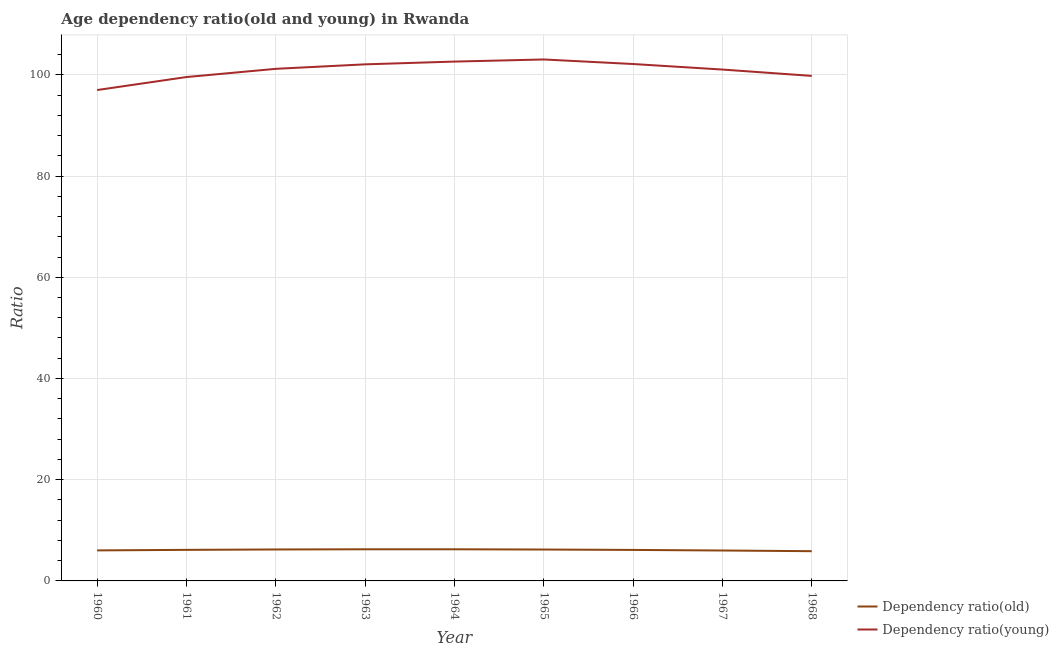How many different coloured lines are there?
Make the answer very short. 2. Does the line corresponding to age dependency ratio(young) intersect with the line corresponding to age dependency ratio(old)?
Offer a very short reply. No. What is the age dependency ratio(young) in 1962?
Your response must be concise. 101.18. Across all years, what is the maximum age dependency ratio(young)?
Your response must be concise. 103.03. Across all years, what is the minimum age dependency ratio(old)?
Provide a short and direct response. 5.87. In which year was the age dependency ratio(old) maximum?
Your answer should be very brief. 1963. In which year was the age dependency ratio(old) minimum?
Your answer should be compact. 1968. What is the total age dependency ratio(young) in the graph?
Your response must be concise. 908.38. What is the difference between the age dependency ratio(young) in 1961 and that in 1965?
Give a very brief answer. -3.47. What is the difference between the age dependency ratio(old) in 1961 and the age dependency ratio(young) in 1963?
Offer a very short reply. -95.93. What is the average age dependency ratio(young) per year?
Keep it short and to the point. 100.93. In the year 1961, what is the difference between the age dependency ratio(young) and age dependency ratio(old)?
Provide a short and direct response. 93.42. What is the ratio of the age dependency ratio(old) in 1961 to that in 1965?
Your response must be concise. 0.99. Is the age dependency ratio(old) in 1960 less than that in 1965?
Provide a succinct answer. Yes. Is the difference between the age dependency ratio(old) in 1962 and 1964 greater than the difference between the age dependency ratio(young) in 1962 and 1964?
Give a very brief answer. Yes. What is the difference between the highest and the second highest age dependency ratio(old)?
Ensure brevity in your answer.  0. What is the difference between the highest and the lowest age dependency ratio(young)?
Offer a very short reply. 6.04. In how many years, is the age dependency ratio(old) greater than the average age dependency ratio(old) taken over all years?
Offer a terse response. 6. Is the sum of the age dependency ratio(old) in 1961 and 1962 greater than the maximum age dependency ratio(young) across all years?
Provide a succinct answer. No. Does the age dependency ratio(young) monotonically increase over the years?
Make the answer very short. No. Is the age dependency ratio(old) strictly greater than the age dependency ratio(young) over the years?
Give a very brief answer. No. Is the age dependency ratio(old) strictly less than the age dependency ratio(young) over the years?
Provide a succinct answer. Yes. How many lines are there?
Offer a terse response. 2. What is the difference between two consecutive major ticks on the Y-axis?
Keep it short and to the point. 20. Are the values on the major ticks of Y-axis written in scientific E-notation?
Ensure brevity in your answer.  No. Where does the legend appear in the graph?
Provide a short and direct response. Bottom right. What is the title of the graph?
Ensure brevity in your answer.  Age dependency ratio(old and young) in Rwanda. Does "% of gross capital formation" appear as one of the legend labels in the graph?
Offer a terse response. No. What is the label or title of the Y-axis?
Your answer should be very brief. Ratio. What is the Ratio of Dependency ratio(old) in 1960?
Ensure brevity in your answer.  6.03. What is the Ratio in Dependency ratio(young) in 1960?
Your answer should be compact. 96.99. What is the Ratio of Dependency ratio(old) in 1961?
Make the answer very short. 6.14. What is the Ratio of Dependency ratio(young) in 1961?
Make the answer very short. 99.56. What is the Ratio of Dependency ratio(old) in 1962?
Make the answer very short. 6.21. What is the Ratio in Dependency ratio(young) in 1962?
Your answer should be compact. 101.18. What is the Ratio of Dependency ratio(old) in 1963?
Offer a terse response. 6.25. What is the Ratio of Dependency ratio(young) in 1963?
Your response must be concise. 102.07. What is the Ratio in Dependency ratio(old) in 1964?
Keep it short and to the point. 6.25. What is the Ratio of Dependency ratio(young) in 1964?
Give a very brief answer. 102.61. What is the Ratio of Dependency ratio(old) in 1965?
Your answer should be compact. 6.2. What is the Ratio in Dependency ratio(young) in 1965?
Make the answer very short. 103.03. What is the Ratio of Dependency ratio(old) in 1966?
Offer a very short reply. 6.12. What is the Ratio of Dependency ratio(young) in 1966?
Offer a terse response. 102.13. What is the Ratio of Dependency ratio(old) in 1967?
Offer a terse response. 6.01. What is the Ratio in Dependency ratio(young) in 1967?
Give a very brief answer. 101.04. What is the Ratio of Dependency ratio(old) in 1968?
Provide a succinct answer. 5.87. What is the Ratio of Dependency ratio(young) in 1968?
Keep it short and to the point. 99.78. Across all years, what is the maximum Ratio in Dependency ratio(old)?
Your answer should be very brief. 6.25. Across all years, what is the maximum Ratio of Dependency ratio(young)?
Your answer should be very brief. 103.03. Across all years, what is the minimum Ratio in Dependency ratio(old)?
Your answer should be compact. 5.87. Across all years, what is the minimum Ratio in Dependency ratio(young)?
Your answer should be very brief. 96.99. What is the total Ratio of Dependency ratio(old) in the graph?
Keep it short and to the point. 55.1. What is the total Ratio of Dependency ratio(young) in the graph?
Ensure brevity in your answer.  908.38. What is the difference between the Ratio in Dependency ratio(old) in 1960 and that in 1961?
Your answer should be very brief. -0.1. What is the difference between the Ratio of Dependency ratio(young) in 1960 and that in 1961?
Your answer should be very brief. -2.57. What is the difference between the Ratio of Dependency ratio(old) in 1960 and that in 1962?
Your response must be concise. -0.18. What is the difference between the Ratio in Dependency ratio(young) in 1960 and that in 1962?
Your response must be concise. -4.19. What is the difference between the Ratio in Dependency ratio(old) in 1960 and that in 1963?
Provide a succinct answer. -0.22. What is the difference between the Ratio in Dependency ratio(young) in 1960 and that in 1963?
Make the answer very short. -5.08. What is the difference between the Ratio of Dependency ratio(old) in 1960 and that in 1964?
Make the answer very short. -0.22. What is the difference between the Ratio of Dependency ratio(young) in 1960 and that in 1964?
Your answer should be compact. -5.62. What is the difference between the Ratio of Dependency ratio(old) in 1960 and that in 1965?
Provide a succinct answer. -0.17. What is the difference between the Ratio in Dependency ratio(young) in 1960 and that in 1965?
Offer a terse response. -6.04. What is the difference between the Ratio in Dependency ratio(old) in 1960 and that in 1966?
Your answer should be very brief. -0.09. What is the difference between the Ratio in Dependency ratio(young) in 1960 and that in 1966?
Provide a short and direct response. -5.14. What is the difference between the Ratio of Dependency ratio(old) in 1960 and that in 1967?
Provide a succinct answer. 0.02. What is the difference between the Ratio of Dependency ratio(young) in 1960 and that in 1967?
Ensure brevity in your answer.  -4.05. What is the difference between the Ratio of Dependency ratio(old) in 1960 and that in 1968?
Your response must be concise. 0.16. What is the difference between the Ratio of Dependency ratio(young) in 1960 and that in 1968?
Offer a very short reply. -2.8. What is the difference between the Ratio of Dependency ratio(old) in 1961 and that in 1962?
Your answer should be very brief. -0.07. What is the difference between the Ratio of Dependency ratio(young) in 1961 and that in 1962?
Keep it short and to the point. -1.62. What is the difference between the Ratio of Dependency ratio(old) in 1961 and that in 1963?
Provide a short and direct response. -0.11. What is the difference between the Ratio in Dependency ratio(young) in 1961 and that in 1963?
Offer a terse response. -2.51. What is the difference between the Ratio of Dependency ratio(old) in 1961 and that in 1964?
Provide a short and direct response. -0.11. What is the difference between the Ratio of Dependency ratio(young) in 1961 and that in 1964?
Your answer should be very brief. -3.06. What is the difference between the Ratio of Dependency ratio(old) in 1961 and that in 1965?
Provide a short and direct response. -0.06. What is the difference between the Ratio of Dependency ratio(young) in 1961 and that in 1965?
Offer a terse response. -3.47. What is the difference between the Ratio of Dependency ratio(old) in 1961 and that in 1966?
Offer a terse response. 0.01. What is the difference between the Ratio of Dependency ratio(young) in 1961 and that in 1966?
Offer a very short reply. -2.57. What is the difference between the Ratio of Dependency ratio(old) in 1961 and that in 1967?
Your answer should be very brief. 0.13. What is the difference between the Ratio in Dependency ratio(young) in 1961 and that in 1967?
Ensure brevity in your answer.  -1.48. What is the difference between the Ratio in Dependency ratio(old) in 1961 and that in 1968?
Your answer should be compact. 0.26. What is the difference between the Ratio in Dependency ratio(young) in 1961 and that in 1968?
Your answer should be compact. -0.23. What is the difference between the Ratio in Dependency ratio(old) in 1962 and that in 1963?
Offer a very short reply. -0.04. What is the difference between the Ratio in Dependency ratio(young) in 1962 and that in 1963?
Make the answer very short. -0.89. What is the difference between the Ratio of Dependency ratio(old) in 1962 and that in 1964?
Give a very brief answer. -0.04. What is the difference between the Ratio of Dependency ratio(young) in 1962 and that in 1964?
Offer a very short reply. -1.43. What is the difference between the Ratio of Dependency ratio(old) in 1962 and that in 1965?
Provide a short and direct response. 0.01. What is the difference between the Ratio of Dependency ratio(young) in 1962 and that in 1965?
Keep it short and to the point. -1.85. What is the difference between the Ratio in Dependency ratio(old) in 1962 and that in 1966?
Keep it short and to the point. 0.09. What is the difference between the Ratio of Dependency ratio(young) in 1962 and that in 1966?
Provide a succinct answer. -0.95. What is the difference between the Ratio of Dependency ratio(old) in 1962 and that in 1967?
Make the answer very short. 0.2. What is the difference between the Ratio of Dependency ratio(young) in 1962 and that in 1967?
Keep it short and to the point. 0.14. What is the difference between the Ratio of Dependency ratio(old) in 1962 and that in 1968?
Offer a terse response. 0.34. What is the difference between the Ratio of Dependency ratio(young) in 1962 and that in 1968?
Make the answer very short. 1.39. What is the difference between the Ratio in Dependency ratio(old) in 1963 and that in 1964?
Make the answer very short. 0. What is the difference between the Ratio of Dependency ratio(young) in 1963 and that in 1964?
Your answer should be very brief. -0.55. What is the difference between the Ratio in Dependency ratio(young) in 1963 and that in 1965?
Make the answer very short. -0.96. What is the difference between the Ratio in Dependency ratio(old) in 1963 and that in 1966?
Make the answer very short. 0.13. What is the difference between the Ratio in Dependency ratio(young) in 1963 and that in 1966?
Keep it short and to the point. -0.06. What is the difference between the Ratio in Dependency ratio(old) in 1963 and that in 1967?
Offer a very short reply. 0.24. What is the difference between the Ratio in Dependency ratio(young) in 1963 and that in 1967?
Ensure brevity in your answer.  1.03. What is the difference between the Ratio of Dependency ratio(old) in 1963 and that in 1968?
Provide a short and direct response. 0.38. What is the difference between the Ratio in Dependency ratio(young) in 1963 and that in 1968?
Offer a very short reply. 2.28. What is the difference between the Ratio in Dependency ratio(old) in 1964 and that in 1965?
Your answer should be compact. 0.05. What is the difference between the Ratio in Dependency ratio(young) in 1964 and that in 1965?
Make the answer very short. -0.42. What is the difference between the Ratio in Dependency ratio(old) in 1964 and that in 1966?
Offer a terse response. 0.13. What is the difference between the Ratio of Dependency ratio(young) in 1964 and that in 1966?
Offer a terse response. 0.48. What is the difference between the Ratio in Dependency ratio(old) in 1964 and that in 1967?
Provide a succinct answer. 0.24. What is the difference between the Ratio in Dependency ratio(young) in 1964 and that in 1967?
Keep it short and to the point. 1.57. What is the difference between the Ratio in Dependency ratio(old) in 1964 and that in 1968?
Make the answer very short. 0.38. What is the difference between the Ratio of Dependency ratio(young) in 1964 and that in 1968?
Provide a succinct answer. 2.83. What is the difference between the Ratio of Dependency ratio(old) in 1965 and that in 1966?
Offer a terse response. 0.08. What is the difference between the Ratio of Dependency ratio(young) in 1965 and that in 1966?
Keep it short and to the point. 0.9. What is the difference between the Ratio in Dependency ratio(old) in 1965 and that in 1967?
Your response must be concise. 0.19. What is the difference between the Ratio in Dependency ratio(young) in 1965 and that in 1967?
Provide a succinct answer. 1.99. What is the difference between the Ratio in Dependency ratio(old) in 1965 and that in 1968?
Offer a very short reply. 0.33. What is the difference between the Ratio in Dependency ratio(young) in 1965 and that in 1968?
Make the answer very short. 3.25. What is the difference between the Ratio of Dependency ratio(old) in 1966 and that in 1967?
Offer a very short reply. 0.11. What is the difference between the Ratio in Dependency ratio(young) in 1966 and that in 1967?
Provide a succinct answer. 1.09. What is the difference between the Ratio of Dependency ratio(old) in 1966 and that in 1968?
Your response must be concise. 0.25. What is the difference between the Ratio in Dependency ratio(young) in 1966 and that in 1968?
Your response must be concise. 2.35. What is the difference between the Ratio in Dependency ratio(old) in 1967 and that in 1968?
Provide a succinct answer. 0.14. What is the difference between the Ratio of Dependency ratio(young) in 1967 and that in 1968?
Provide a succinct answer. 1.25. What is the difference between the Ratio in Dependency ratio(old) in 1960 and the Ratio in Dependency ratio(young) in 1961?
Your answer should be very brief. -93.52. What is the difference between the Ratio in Dependency ratio(old) in 1960 and the Ratio in Dependency ratio(young) in 1962?
Your response must be concise. -95.14. What is the difference between the Ratio of Dependency ratio(old) in 1960 and the Ratio of Dependency ratio(young) in 1963?
Offer a very short reply. -96.03. What is the difference between the Ratio of Dependency ratio(old) in 1960 and the Ratio of Dependency ratio(young) in 1964?
Offer a very short reply. -96.58. What is the difference between the Ratio of Dependency ratio(old) in 1960 and the Ratio of Dependency ratio(young) in 1965?
Give a very brief answer. -97. What is the difference between the Ratio of Dependency ratio(old) in 1960 and the Ratio of Dependency ratio(young) in 1966?
Your answer should be very brief. -96.1. What is the difference between the Ratio in Dependency ratio(old) in 1960 and the Ratio in Dependency ratio(young) in 1967?
Offer a terse response. -95. What is the difference between the Ratio in Dependency ratio(old) in 1960 and the Ratio in Dependency ratio(young) in 1968?
Make the answer very short. -93.75. What is the difference between the Ratio in Dependency ratio(old) in 1961 and the Ratio in Dependency ratio(young) in 1962?
Give a very brief answer. -95.04. What is the difference between the Ratio in Dependency ratio(old) in 1961 and the Ratio in Dependency ratio(young) in 1963?
Offer a very short reply. -95.93. What is the difference between the Ratio of Dependency ratio(old) in 1961 and the Ratio of Dependency ratio(young) in 1964?
Offer a very short reply. -96.47. What is the difference between the Ratio in Dependency ratio(old) in 1961 and the Ratio in Dependency ratio(young) in 1965?
Your answer should be very brief. -96.89. What is the difference between the Ratio of Dependency ratio(old) in 1961 and the Ratio of Dependency ratio(young) in 1966?
Offer a terse response. -95.99. What is the difference between the Ratio of Dependency ratio(old) in 1961 and the Ratio of Dependency ratio(young) in 1967?
Make the answer very short. -94.9. What is the difference between the Ratio in Dependency ratio(old) in 1961 and the Ratio in Dependency ratio(young) in 1968?
Your answer should be very brief. -93.65. What is the difference between the Ratio of Dependency ratio(old) in 1962 and the Ratio of Dependency ratio(young) in 1963?
Make the answer very short. -95.85. What is the difference between the Ratio of Dependency ratio(old) in 1962 and the Ratio of Dependency ratio(young) in 1964?
Your answer should be very brief. -96.4. What is the difference between the Ratio of Dependency ratio(old) in 1962 and the Ratio of Dependency ratio(young) in 1965?
Offer a terse response. -96.82. What is the difference between the Ratio in Dependency ratio(old) in 1962 and the Ratio in Dependency ratio(young) in 1966?
Provide a short and direct response. -95.92. What is the difference between the Ratio in Dependency ratio(old) in 1962 and the Ratio in Dependency ratio(young) in 1967?
Ensure brevity in your answer.  -94.82. What is the difference between the Ratio of Dependency ratio(old) in 1962 and the Ratio of Dependency ratio(young) in 1968?
Ensure brevity in your answer.  -93.57. What is the difference between the Ratio of Dependency ratio(old) in 1963 and the Ratio of Dependency ratio(young) in 1964?
Your answer should be very brief. -96.36. What is the difference between the Ratio in Dependency ratio(old) in 1963 and the Ratio in Dependency ratio(young) in 1965?
Your answer should be compact. -96.78. What is the difference between the Ratio in Dependency ratio(old) in 1963 and the Ratio in Dependency ratio(young) in 1966?
Your answer should be compact. -95.88. What is the difference between the Ratio of Dependency ratio(old) in 1963 and the Ratio of Dependency ratio(young) in 1967?
Give a very brief answer. -94.78. What is the difference between the Ratio of Dependency ratio(old) in 1963 and the Ratio of Dependency ratio(young) in 1968?
Your answer should be compact. -93.53. What is the difference between the Ratio in Dependency ratio(old) in 1964 and the Ratio in Dependency ratio(young) in 1965?
Provide a succinct answer. -96.78. What is the difference between the Ratio in Dependency ratio(old) in 1964 and the Ratio in Dependency ratio(young) in 1966?
Your response must be concise. -95.88. What is the difference between the Ratio of Dependency ratio(old) in 1964 and the Ratio of Dependency ratio(young) in 1967?
Provide a succinct answer. -94.79. What is the difference between the Ratio of Dependency ratio(old) in 1964 and the Ratio of Dependency ratio(young) in 1968?
Give a very brief answer. -93.53. What is the difference between the Ratio of Dependency ratio(old) in 1965 and the Ratio of Dependency ratio(young) in 1966?
Give a very brief answer. -95.93. What is the difference between the Ratio in Dependency ratio(old) in 1965 and the Ratio in Dependency ratio(young) in 1967?
Offer a terse response. -94.83. What is the difference between the Ratio of Dependency ratio(old) in 1965 and the Ratio of Dependency ratio(young) in 1968?
Offer a very short reply. -93.58. What is the difference between the Ratio in Dependency ratio(old) in 1966 and the Ratio in Dependency ratio(young) in 1967?
Provide a succinct answer. -94.91. What is the difference between the Ratio of Dependency ratio(old) in 1966 and the Ratio of Dependency ratio(young) in 1968?
Provide a succinct answer. -93.66. What is the difference between the Ratio of Dependency ratio(old) in 1967 and the Ratio of Dependency ratio(young) in 1968?
Make the answer very short. -93.77. What is the average Ratio of Dependency ratio(old) per year?
Offer a very short reply. 6.12. What is the average Ratio of Dependency ratio(young) per year?
Ensure brevity in your answer.  100.93. In the year 1960, what is the difference between the Ratio in Dependency ratio(old) and Ratio in Dependency ratio(young)?
Keep it short and to the point. -90.95. In the year 1961, what is the difference between the Ratio in Dependency ratio(old) and Ratio in Dependency ratio(young)?
Make the answer very short. -93.42. In the year 1962, what is the difference between the Ratio of Dependency ratio(old) and Ratio of Dependency ratio(young)?
Offer a terse response. -94.97. In the year 1963, what is the difference between the Ratio of Dependency ratio(old) and Ratio of Dependency ratio(young)?
Give a very brief answer. -95.81. In the year 1964, what is the difference between the Ratio in Dependency ratio(old) and Ratio in Dependency ratio(young)?
Your response must be concise. -96.36. In the year 1965, what is the difference between the Ratio in Dependency ratio(old) and Ratio in Dependency ratio(young)?
Your response must be concise. -96.83. In the year 1966, what is the difference between the Ratio in Dependency ratio(old) and Ratio in Dependency ratio(young)?
Offer a terse response. -96.01. In the year 1967, what is the difference between the Ratio in Dependency ratio(old) and Ratio in Dependency ratio(young)?
Keep it short and to the point. -95.03. In the year 1968, what is the difference between the Ratio of Dependency ratio(old) and Ratio of Dependency ratio(young)?
Make the answer very short. -93.91. What is the ratio of the Ratio in Dependency ratio(young) in 1960 to that in 1961?
Provide a short and direct response. 0.97. What is the ratio of the Ratio in Dependency ratio(old) in 1960 to that in 1962?
Your response must be concise. 0.97. What is the ratio of the Ratio of Dependency ratio(young) in 1960 to that in 1962?
Make the answer very short. 0.96. What is the ratio of the Ratio in Dependency ratio(young) in 1960 to that in 1963?
Your answer should be very brief. 0.95. What is the ratio of the Ratio in Dependency ratio(old) in 1960 to that in 1964?
Keep it short and to the point. 0.97. What is the ratio of the Ratio in Dependency ratio(young) in 1960 to that in 1964?
Your response must be concise. 0.95. What is the ratio of the Ratio of Dependency ratio(old) in 1960 to that in 1965?
Your answer should be compact. 0.97. What is the ratio of the Ratio in Dependency ratio(young) in 1960 to that in 1965?
Your answer should be very brief. 0.94. What is the ratio of the Ratio in Dependency ratio(old) in 1960 to that in 1966?
Provide a succinct answer. 0.99. What is the ratio of the Ratio of Dependency ratio(young) in 1960 to that in 1966?
Offer a terse response. 0.95. What is the ratio of the Ratio in Dependency ratio(old) in 1960 to that in 1967?
Offer a very short reply. 1. What is the ratio of the Ratio in Dependency ratio(young) in 1960 to that in 1967?
Give a very brief answer. 0.96. What is the ratio of the Ratio in Dependency ratio(old) in 1960 to that in 1968?
Your answer should be very brief. 1.03. What is the ratio of the Ratio in Dependency ratio(young) in 1960 to that in 1968?
Provide a short and direct response. 0.97. What is the ratio of the Ratio in Dependency ratio(old) in 1961 to that in 1962?
Your response must be concise. 0.99. What is the ratio of the Ratio of Dependency ratio(young) in 1961 to that in 1962?
Give a very brief answer. 0.98. What is the ratio of the Ratio of Dependency ratio(old) in 1961 to that in 1963?
Give a very brief answer. 0.98. What is the ratio of the Ratio in Dependency ratio(young) in 1961 to that in 1963?
Ensure brevity in your answer.  0.98. What is the ratio of the Ratio of Dependency ratio(old) in 1961 to that in 1964?
Your answer should be compact. 0.98. What is the ratio of the Ratio of Dependency ratio(young) in 1961 to that in 1964?
Offer a terse response. 0.97. What is the ratio of the Ratio of Dependency ratio(old) in 1961 to that in 1965?
Ensure brevity in your answer.  0.99. What is the ratio of the Ratio of Dependency ratio(young) in 1961 to that in 1965?
Provide a succinct answer. 0.97. What is the ratio of the Ratio of Dependency ratio(young) in 1961 to that in 1966?
Your answer should be compact. 0.97. What is the ratio of the Ratio in Dependency ratio(old) in 1961 to that in 1967?
Ensure brevity in your answer.  1.02. What is the ratio of the Ratio in Dependency ratio(old) in 1961 to that in 1968?
Give a very brief answer. 1.04. What is the ratio of the Ratio of Dependency ratio(young) in 1961 to that in 1968?
Your answer should be compact. 1. What is the ratio of the Ratio of Dependency ratio(young) in 1962 to that in 1964?
Give a very brief answer. 0.99. What is the ratio of the Ratio in Dependency ratio(old) in 1962 to that in 1965?
Your response must be concise. 1. What is the ratio of the Ratio in Dependency ratio(old) in 1962 to that in 1966?
Give a very brief answer. 1.01. What is the ratio of the Ratio of Dependency ratio(young) in 1962 to that in 1966?
Your response must be concise. 0.99. What is the ratio of the Ratio of Dependency ratio(old) in 1962 to that in 1967?
Provide a succinct answer. 1.03. What is the ratio of the Ratio of Dependency ratio(old) in 1962 to that in 1968?
Provide a succinct answer. 1.06. What is the ratio of the Ratio in Dependency ratio(young) in 1962 to that in 1968?
Provide a short and direct response. 1.01. What is the ratio of the Ratio in Dependency ratio(old) in 1963 to that in 1964?
Offer a very short reply. 1. What is the ratio of the Ratio of Dependency ratio(old) in 1963 to that in 1965?
Your answer should be very brief. 1.01. What is the ratio of the Ratio of Dependency ratio(young) in 1963 to that in 1965?
Give a very brief answer. 0.99. What is the ratio of the Ratio in Dependency ratio(old) in 1963 to that in 1966?
Make the answer very short. 1.02. What is the ratio of the Ratio in Dependency ratio(old) in 1963 to that in 1967?
Your response must be concise. 1.04. What is the ratio of the Ratio in Dependency ratio(young) in 1963 to that in 1967?
Your response must be concise. 1.01. What is the ratio of the Ratio in Dependency ratio(old) in 1963 to that in 1968?
Ensure brevity in your answer.  1.06. What is the ratio of the Ratio of Dependency ratio(young) in 1963 to that in 1968?
Provide a succinct answer. 1.02. What is the ratio of the Ratio in Dependency ratio(old) in 1964 to that in 1965?
Your answer should be compact. 1.01. What is the ratio of the Ratio of Dependency ratio(old) in 1964 to that in 1966?
Offer a very short reply. 1.02. What is the ratio of the Ratio of Dependency ratio(young) in 1964 to that in 1966?
Offer a very short reply. 1. What is the ratio of the Ratio in Dependency ratio(old) in 1964 to that in 1967?
Ensure brevity in your answer.  1.04. What is the ratio of the Ratio in Dependency ratio(young) in 1964 to that in 1967?
Make the answer very short. 1.02. What is the ratio of the Ratio in Dependency ratio(old) in 1964 to that in 1968?
Give a very brief answer. 1.06. What is the ratio of the Ratio of Dependency ratio(young) in 1964 to that in 1968?
Your answer should be compact. 1.03. What is the ratio of the Ratio of Dependency ratio(old) in 1965 to that in 1966?
Your answer should be compact. 1.01. What is the ratio of the Ratio of Dependency ratio(young) in 1965 to that in 1966?
Provide a succinct answer. 1.01. What is the ratio of the Ratio in Dependency ratio(old) in 1965 to that in 1967?
Offer a very short reply. 1.03. What is the ratio of the Ratio of Dependency ratio(young) in 1965 to that in 1967?
Provide a succinct answer. 1.02. What is the ratio of the Ratio in Dependency ratio(old) in 1965 to that in 1968?
Offer a very short reply. 1.06. What is the ratio of the Ratio of Dependency ratio(young) in 1965 to that in 1968?
Provide a short and direct response. 1.03. What is the ratio of the Ratio in Dependency ratio(old) in 1966 to that in 1967?
Ensure brevity in your answer.  1.02. What is the ratio of the Ratio of Dependency ratio(young) in 1966 to that in 1967?
Offer a terse response. 1.01. What is the ratio of the Ratio in Dependency ratio(old) in 1966 to that in 1968?
Offer a very short reply. 1.04. What is the ratio of the Ratio in Dependency ratio(young) in 1966 to that in 1968?
Ensure brevity in your answer.  1.02. What is the ratio of the Ratio in Dependency ratio(old) in 1967 to that in 1968?
Your answer should be compact. 1.02. What is the ratio of the Ratio in Dependency ratio(young) in 1967 to that in 1968?
Your answer should be very brief. 1.01. What is the difference between the highest and the second highest Ratio of Dependency ratio(old)?
Give a very brief answer. 0. What is the difference between the highest and the second highest Ratio of Dependency ratio(young)?
Your response must be concise. 0.42. What is the difference between the highest and the lowest Ratio of Dependency ratio(old)?
Provide a succinct answer. 0.38. What is the difference between the highest and the lowest Ratio of Dependency ratio(young)?
Provide a succinct answer. 6.04. 